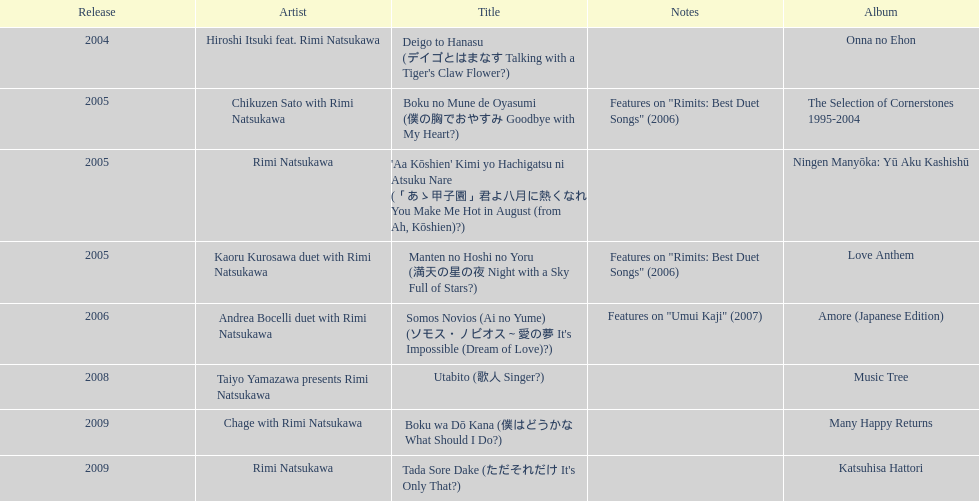What song was this artist on after utabito? Boku wa Dō Kana. 